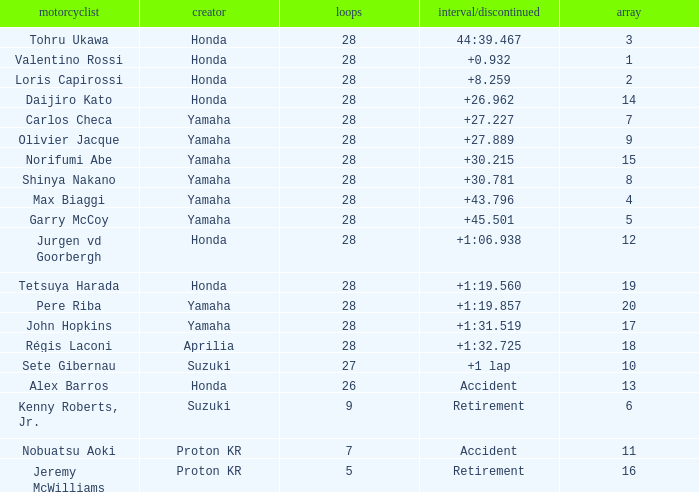How many laps were in grid 4? 28.0. 